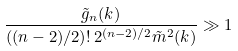Convert formula to latex. <formula><loc_0><loc_0><loc_500><loc_500>\frac { \tilde { g } _ { n } ( k ) } { ( ( n - 2 ) / 2 ) ! \, 2 ^ { ( n - 2 ) / 2 } \tilde { m } ^ { 2 } ( k ) } \gg 1</formula> 